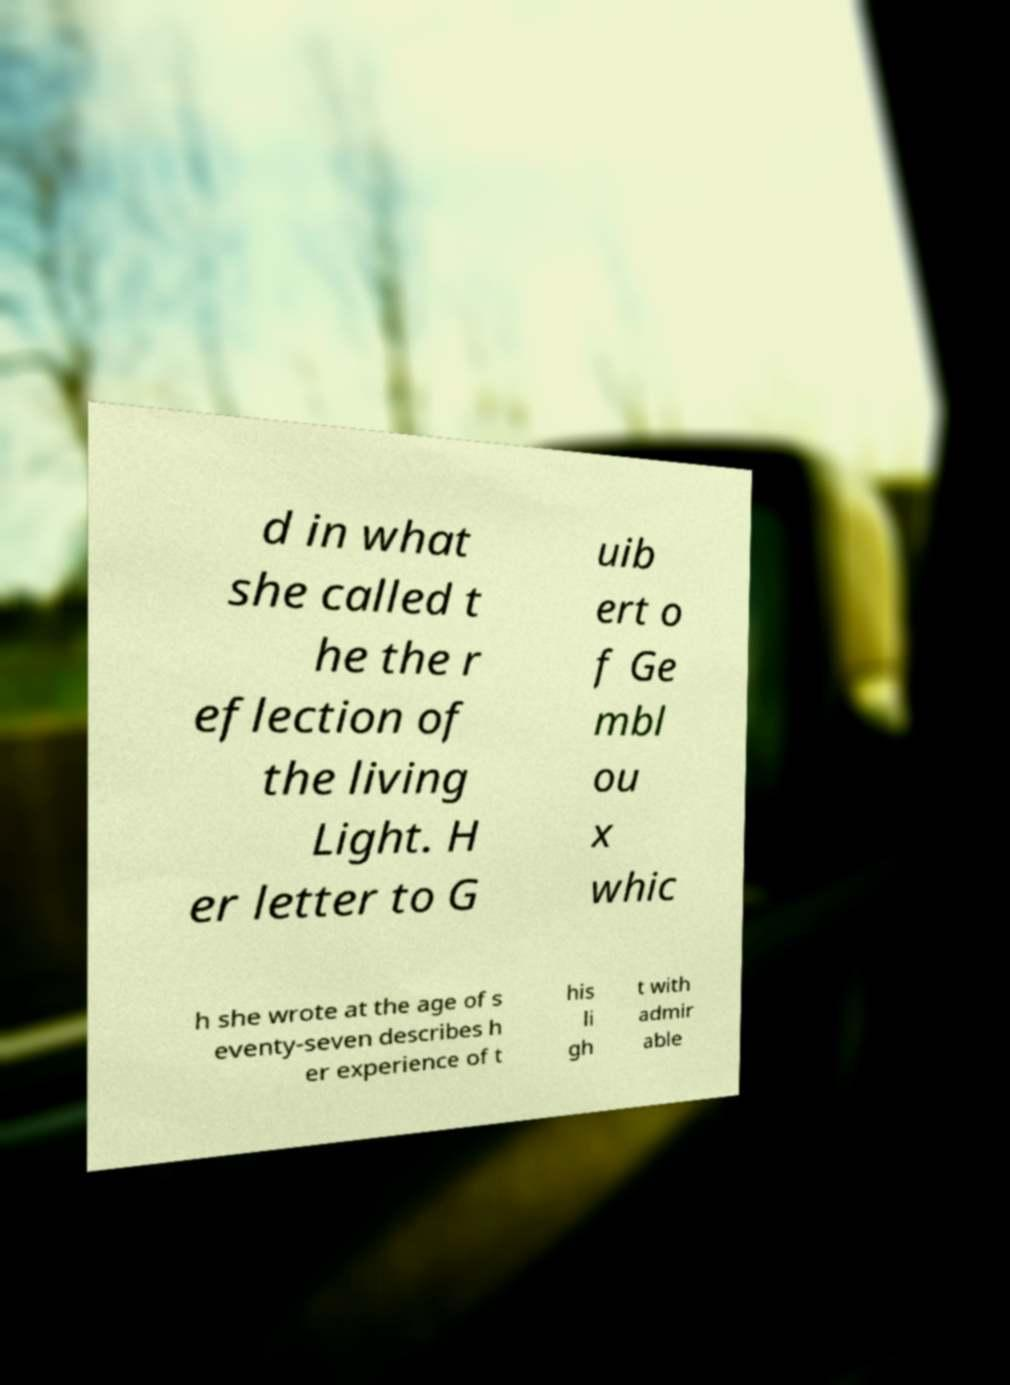For documentation purposes, I need the text within this image transcribed. Could you provide that? d in what she called t he the r eflection of the living Light. H er letter to G uib ert o f Ge mbl ou x whic h she wrote at the age of s eventy-seven describes h er experience of t his li gh t with admir able 